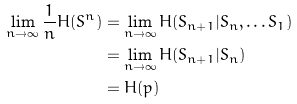Convert formula to latex. <formula><loc_0><loc_0><loc_500><loc_500>\lim _ { n \to \infty } \frac { 1 } { n } H ( S ^ { n } ) & = \lim _ { n \to \infty } { H ( S _ { n + 1 } | S _ { n } , \dots S _ { 1 } ) } \\ & = \lim _ { n \to \infty } { H ( S _ { n + 1 } | S _ { n } ) } \\ & = H ( p )</formula> 